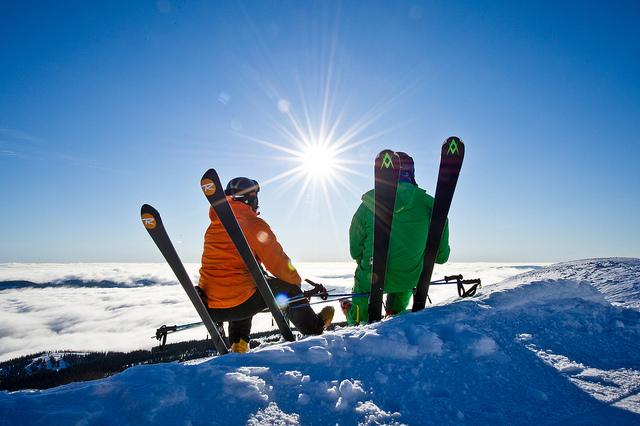Does the skis match the skiers jackets?
Answer briefly. Yes. What are these two people doing?
Answer briefly. Sitting. What are the skiers doing?
Keep it brief. Sitting. 